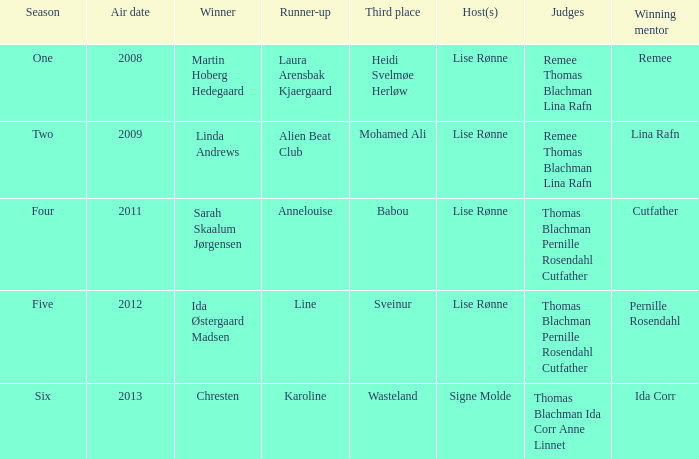Which season did ida corr triumph? Six. 